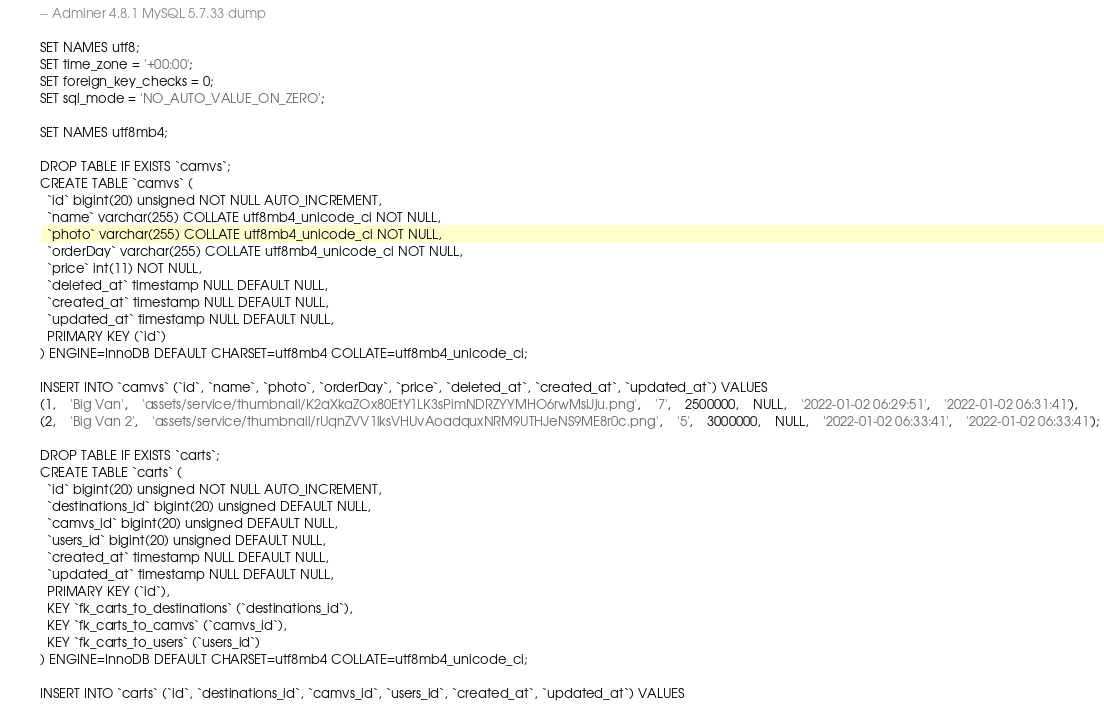<code> <loc_0><loc_0><loc_500><loc_500><_SQL_>-- Adminer 4.8.1 MySQL 5.7.33 dump

SET NAMES utf8;
SET time_zone = '+00:00';
SET foreign_key_checks = 0;
SET sql_mode = 'NO_AUTO_VALUE_ON_ZERO';

SET NAMES utf8mb4;

DROP TABLE IF EXISTS `camvs`;
CREATE TABLE `camvs` (
  `id` bigint(20) unsigned NOT NULL AUTO_INCREMENT,
  `name` varchar(255) COLLATE utf8mb4_unicode_ci NOT NULL,
  `photo` varchar(255) COLLATE utf8mb4_unicode_ci NOT NULL,
  `orderDay` varchar(255) COLLATE utf8mb4_unicode_ci NOT NULL,
  `price` int(11) NOT NULL,
  `deleted_at` timestamp NULL DEFAULT NULL,
  `created_at` timestamp NULL DEFAULT NULL,
  `updated_at` timestamp NULL DEFAULT NULL,
  PRIMARY KEY (`id`)
) ENGINE=InnoDB DEFAULT CHARSET=utf8mb4 COLLATE=utf8mb4_unicode_ci;

INSERT INTO `camvs` (`id`, `name`, `photo`, `orderDay`, `price`, `deleted_at`, `created_at`, `updated_at`) VALUES
(1,	'Big Van',	'assets/service/thumbnail/K2aXkaZOx80EtY1LK3sPimNDRZYYMHO6rwMsiJju.png',	'7',	2500000,	NULL,	'2022-01-02 06:29:51',	'2022-01-02 06:31:41'),
(2,	'Big Van 2',	'assets/service/thumbnail/rUqnZVV1lksVHUvAoadquxNRM9UTHJeNS9ME8r0c.png',	'5',	3000000,	NULL,	'2022-01-02 06:33:41',	'2022-01-02 06:33:41');

DROP TABLE IF EXISTS `carts`;
CREATE TABLE `carts` (
  `id` bigint(20) unsigned NOT NULL AUTO_INCREMENT,
  `destinations_id` bigint(20) unsigned DEFAULT NULL,
  `camvs_id` bigint(20) unsigned DEFAULT NULL,
  `users_id` bigint(20) unsigned DEFAULT NULL,
  `created_at` timestamp NULL DEFAULT NULL,
  `updated_at` timestamp NULL DEFAULT NULL,
  PRIMARY KEY (`id`),
  KEY `fk_carts_to_destinations` (`destinations_id`),
  KEY `fk_carts_to_camvs` (`camvs_id`),
  KEY `fk_carts_to_users` (`users_id`)
) ENGINE=InnoDB DEFAULT CHARSET=utf8mb4 COLLATE=utf8mb4_unicode_ci;

INSERT INTO `carts` (`id`, `destinations_id`, `camvs_id`, `users_id`, `created_at`, `updated_at`) VALUES</code> 